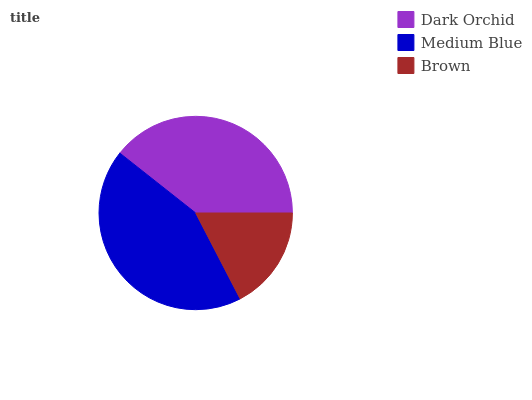Is Brown the minimum?
Answer yes or no. Yes. Is Medium Blue the maximum?
Answer yes or no. Yes. Is Medium Blue the minimum?
Answer yes or no. No. Is Brown the maximum?
Answer yes or no. No. Is Medium Blue greater than Brown?
Answer yes or no. Yes. Is Brown less than Medium Blue?
Answer yes or no. Yes. Is Brown greater than Medium Blue?
Answer yes or no. No. Is Medium Blue less than Brown?
Answer yes or no. No. Is Dark Orchid the high median?
Answer yes or no. Yes. Is Dark Orchid the low median?
Answer yes or no. Yes. Is Brown the high median?
Answer yes or no. No. Is Brown the low median?
Answer yes or no. No. 